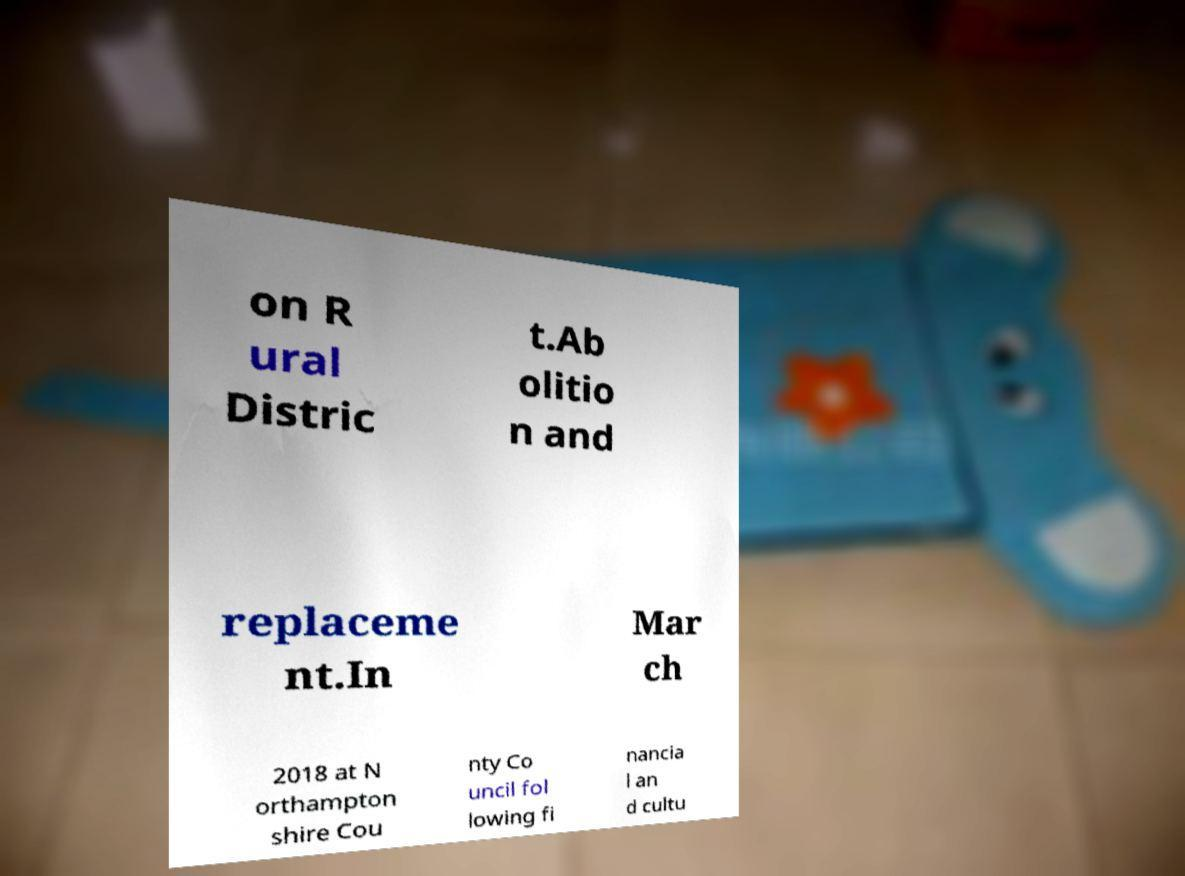There's text embedded in this image that I need extracted. Can you transcribe it verbatim? on R ural Distric t.Ab olitio n and replaceme nt.In Mar ch 2018 at N orthampton shire Cou nty Co uncil fol lowing fi nancia l an d cultu 